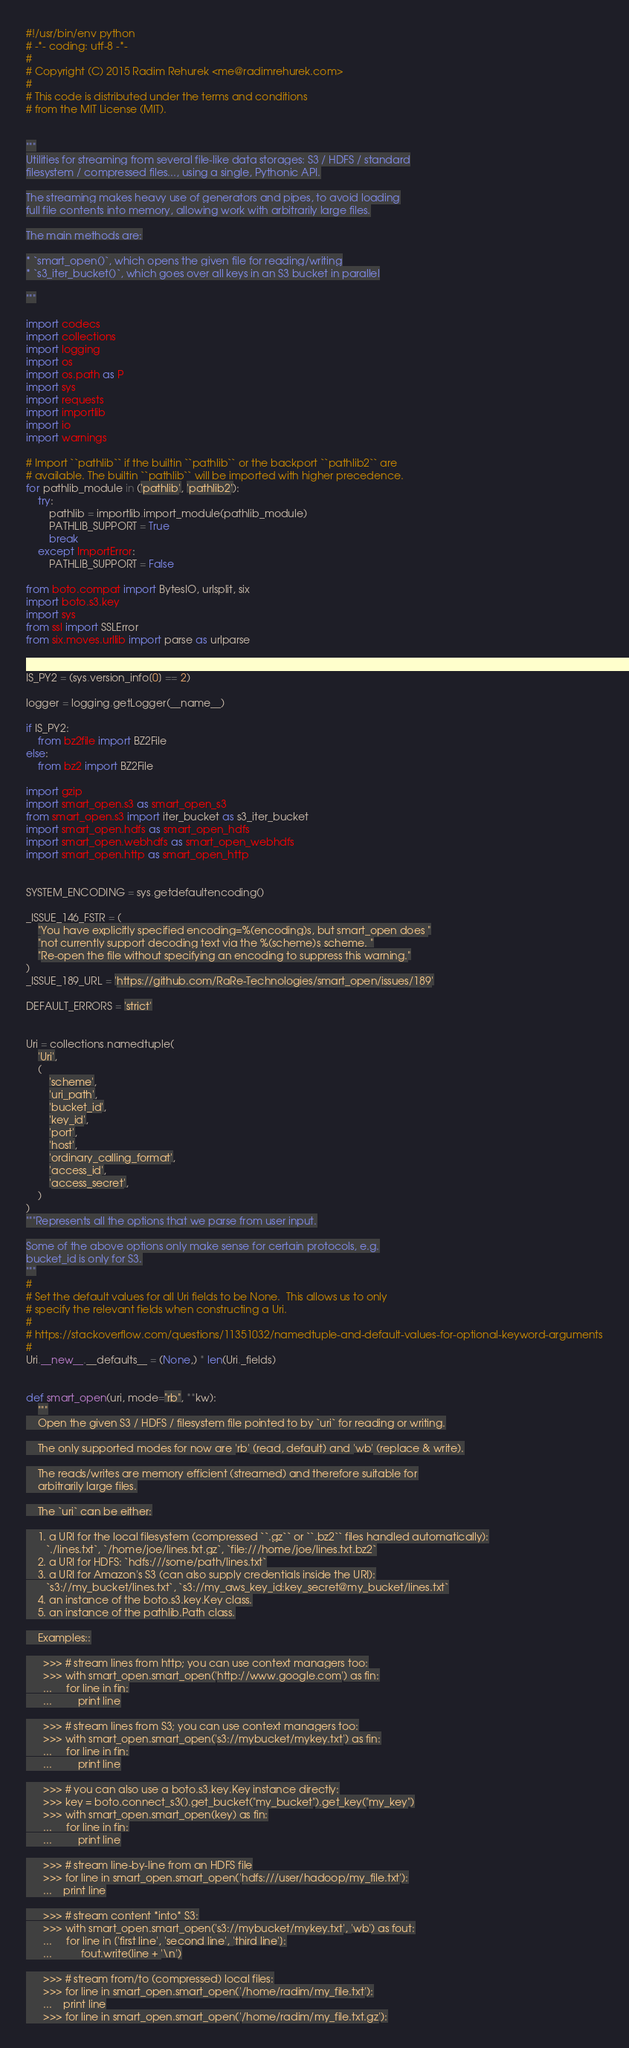Convert code to text. <code><loc_0><loc_0><loc_500><loc_500><_Python_>#!/usr/bin/env python
# -*- coding: utf-8 -*-
#
# Copyright (C) 2015 Radim Rehurek <me@radimrehurek.com>
#
# This code is distributed under the terms and conditions
# from the MIT License (MIT).


"""
Utilities for streaming from several file-like data storages: S3 / HDFS / standard
filesystem / compressed files..., using a single, Pythonic API.

The streaming makes heavy use of generators and pipes, to avoid loading
full file contents into memory, allowing work with arbitrarily large files.

The main methods are:

* `smart_open()`, which opens the given file for reading/writing
* `s3_iter_bucket()`, which goes over all keys in an S3 bucket in parallel

"""

import codecs
import collections
import logging
import os
import os.path as P
import sys
import requests
import importlib
import io
import warnings

# Import ``pathlib`` if the builtin ``pathlib`` or the backport ``pathlib2`` are
# available. The builtin ``pathlib`` will be imported with higher precedence.
for pathlib_module in ('pathlib', 'pathlib2'):
    try:
        pathlib = importlib.import_module(pathlib_module)
        PATHLIB_SUPPORT = True
        break
    except ImportError:
        PATHLIB_SUPPORT = False

from boto.compat import BytesIO, urlsplit, six
import boto.s3.key
import sys
from ssl import SSLError
from six.moves.urllib import parse as urlparse


IS_PY2 = (sys.version_info[0] == 2)

logger = logging.getLogger(__name__)

if IS_PY2:
    from bz2file import BZ2File
else:
    from bz2 import BZ2File

import gzip
import smart_open.s3 as smart_open_s3
from smart_open.s3 import iter_bucket as s3_iter_bucket
import smart_open.hdfs as smart_open_hdfs
import smart_open.webhdfs as smart_open_webhdfs
import smart_open.http as smart_open_http


SYSTEM_ENCODING = sys.getdefaultencoding()

_ISSUE_146_FSTR = (
    "You have explicitly specified encoding=%(encoding)s, but smart_open does "
    "not currently support decoding text via the %(scheme)s scheme. "
    "Re-open the file without specifying an encoding to suppress this warning."
)
_ISSUE_189_URL = 'https://github.com/RaRe-Technologies/smart_open/issues/189'

DEFAULT_ERRORS = 'strict'


Uri = collections.namedtuple(
    'Uri', 
    (
        'scheme',
        'uri_path',
        'bucket_id',
        'key_id',
        'port',
        'host',
        'ordinary_calling_format',
        'access_id',
        'access_secret',
    )
)
"""Represents all the options that we parse from user input.

Some of the above options only make sense for certain protocols, e.g.
bucket_id is only for S3.
"""
#
# Set the default values for all Uri fields to be None.  This allows us to only
# specify the relevant fields when constructing a Uri.
#
# https://stackoverflow.com/questions/11351032/namedtuple-and-default-values-for-optional-keyword-arguments
#
Uri.__new__.__defaults__ = (None,) * len(Uri._fields)


def smart_open(uri, mode="rb", **kw):
    """
    Open the given S3 / HDFS / filesystem file pointed to by `uri` for reading or writing.

    The only supported modes for now are 'rb' (read, default) and 'wb' (replace & write).

    The reads/writes are memory efficient (streamed) and therefore suitable for
    arbitrarily large files.

    The `uri` can be either:

    1. a URI for the local filesystem (compressed ``.gz`` or ``.bz2`` files handled automatically):
       `./lines.txt`, `/home/joe/lines.txt.gz`, `file:///home/joe/lines.txt.bz2`
    2. a URI for HDFS: `hdfs:///some/path/lines.txt`
    3. a URI for Amazon's S3 (can also supply credentials inside the URI):
       `s3://my_bucket/lines.txt`, `s3://my_aws_key_id:key_secret@my_bucket/lines.txt`
    4. an instance of the boto.s3.key.Key class.
    5. an instance of the pathlib.Path class.

    Examples::

      >>> # stream lines from http; you can use context managers too:
      >>> with smart_open.smart_open('http://www.google.com') as fin:
      ...     for line in fin:
      ...         print line

      >>> # stream lines from S3; you can use context managers too:
      >>> with smart_open.smart_open('s3://mybucket/mykey.txt') as fin:
      ...     for line in fin:
      ...         print line

      >>> # you can also use a boto.s3.key.Key instance directly:
      >>> key = boto.connect_s3().get_bucket("my_bucket").get_key("my_key")
      >>> with smart_open.smart_open(key) as fin:
      ...     for line in fin:
      ...         print line

      >>> # stream line-by-line from an HDFS file
      >>> for line in smart_open.smart_open('hdfs:///user/hadoop/my_file.txt'):
      ...    print line

      >>> # stream content *into* S3:
      >>> with smart_open.smart_open('s3://mybucket/mykey.txt', 'wb') as fout:
      ...     for line in ['first line', 'second line', 'third line']:
      ...          fout.write(line + '\n')

      >>> # stream from/to (compressed) local files:
      >>> for line in smart_open.smart_open('/home/radim/my_file.txt'):
      ...    print line
      >>> for line in smart_open.smart_open('/home/radim/my_file.txt.gz'):</code> 